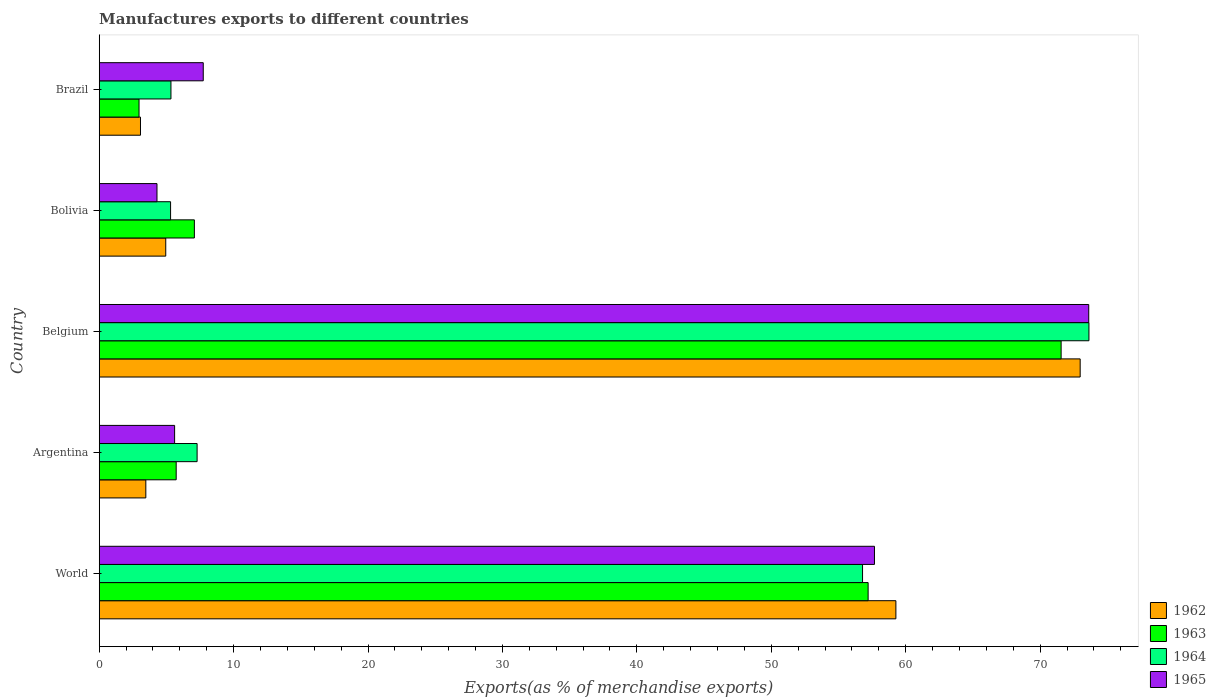How many different coloured bars are there?
Offer a terse response. 4. What is the label of the 4th group of bars from the top?
Offer a terse response. Argentina. In how many cases, is the number of bars for a given country not equal to the number of legend labels?
Provide a short and direct response. 0. What is the percentage of exports to different countries in 1964 in Argentina?
Offer a terse response. 7.28. Across all countries, what is the maximum percentage of exports to different countries in 1964?
Provide a succinct answer. 73.63. Across all countries, what is the minimum percentage of exports to different countries in 1965?
Your answer should be compact. 4.3. In which country was the percentage of exports to different countries in 1965 maximum?
Make the answer very short. Belgium. What is the total percentage of exports to different countries in 1962 in the graph?
Give a very brief answer. 143.74. What is the difference between the percentage of exports to different countries in 1963 in Argentina and that in World?
Offer a very short reply. -51.48. What is the difference between the percentage of exports to different countries in 1963 in Bolivia and the percentage of exports to different countries in 1965 in World?
Offer a very short reply. -50.6. What is the average percentage of exports to different countries in 1962 per country?
Offer a terse response. 28.75. What is the difference between the percentage of exports to different countries in 1963 and percentage of exports to different countries in 1962 in Bolivia?
Your response must be concise. 2.13. In how many countries, is the percentage of exports to different countries in 1963 greater than 44 %?
Offer a terse response. 2. What is the ratio of the percentage of exports to different countries in 1962 in Argentina to that in Belgium?
Offer a terse response. 0.05. Is the difference between the percentage of exports to different countries in 1963 in Argentina and Bolivia greater than the difference between the percentage of exports to different countries in 1962 in Argentina and Bolivia?
Give a very brief answer. Yes. What is the difference between the highest and the second highest percentage of exports to different countries in 1962?
Keep it short and to the point. 13.71. What is the difference between the highest and the lowest percentage of exports to different countries in 1962?
Offer a terse response. 69.91. In how many countries, is the percentage of exports to different countries in 1963 greater than the average percentage of exports to different countries in 1963 taken over all countries?
Keep it short and to the point. 2. What does the 3rd bar from the top in Belgium represents?
Provide a succinct answer. 1963. What does the 2nd bar from the bottom in World represents?
Keep it short and to the point. 1963. Is it the case that in every country, the sum of the percentage of exports to different countries in 1963 and percentage of exports to different countries in 1965 is greater than the percentage of exports to different countries in 1962?
Provide a succinct answer. Yes. Are all the bars in the graph horizontal?
Keep it short and to the point. Yes. Are the values on the major ticks of X-axis written in scientific E-notation?
Offer a terse response. No. Does the graph contain any zero values?
Offer a very short reply. No. Does the graph contain grids?
Your answer should be compact. No. How many legend labels are there?
Keep it short and to the point. 4. What is the title of the graph?
Make the answer very short. Manufactures exports to different countries. What is the label or title of the X-axis?
Give a very brief answer. Exports(as % of merchandise exports). What is the Exports(as % of merchandise exports) of 1962 in World?
Provide a succinct answer. 59.27. What is the Exports(as % of merchandise exports) of 1963 in World?
Provide a succinct answer. 57.2. What is the Exports(as % of merchandise exports) in 1964 in World?
Provide a succinct answer. 56.79. What is the Exports(as % of merchandise exports) in 1965 in World?
Your answer should be very brief. 57.68. What is the Exports(as % of merchandise exports) of 1962 in Argentina?
Keep it short and to the point. 3.47. What is the Exports(as % of merchandise exports) in 1963 in Argentina?
Ensure brevity in your answer.  5.73. What is the Exports(as % of merchandise exports) of 1964 in Argentina?
Make the answer very short. 7.28. What is the Exports(as % of merchandise exports) of 1965 in Argentina?
Keep it short and to the point. 5.61. What is the Exports(as % of merchandise exports) of 1962 in Belgium?
Your answer should be very brief. 72.98. What is the Exports(as % of merchandise exports) of 1963 in Belgium?
Provide a succinct answer. 71.56. What is the Exports(as % of merchandise exports) in 1964 in Belgium?
Your answer should be very brief. 73.63. What is the Exports(as % of merchandise exports) in 1965 in Belgium?
Provide a short and direct response. 73.62. What is the Exports(as % of merchandise exports) of 1962 in Bolivia?
Your answer should be very brief. 4.95. What is the Exports(as % of merchandise exports) in 1963 in Bolivia?
Give a very brief answer. 7.08. What is the Exports(as % of merchandise exports) of 1964 in Bolivia?
Your answer should be compact. 5.31. What is the Exports(as % of merchandise exports) in 1965 in Bolivia?
Offer a terse response. 4.3. What is the Exports(as % of merchandise exports) of 1962 in Brazil?
Offer a very short reply. 3.07. What is the Exports(as % of merchandise exports) in 1963 in Brazil?
Ensure brevity in your answer.  2.96. What is the Exports(as % of merchandise exports) of 1964 in Brazil?
Give a very brief answer. 5.34. What is the Exports(as % of merchandise exports) of 1965 in Brazil?
Your answer should be compact. 7.74. Across all countries, what is the maximum Exports(as % of merchandise exports) in 1962?
Keep it short and to the point. 72.98. Across all countries, what is the maximum Exports(as % of merchandise exports) of 1963?
Keep it short and to the point. 71.56. Across all countries, what is the maximum Exports(as % of merchandise exports) in 1964?
Provide a short and direct response. 73.63. Across all countries, what is the maximum Exports(as % of merchandise exports) in 1965?
Offer a very short reply. 73.62. Across all countries, what is the minimum Exports(as % of merchandise exports) of 1962?
Provide a succinct answer. 3.07. Across all countries, what is the minimum Exports(as % of merchandise exports) in 1963?
Ensure brevity in your answer.  2.96. Across all countries, what is the minimum Exports(as % of merchandise exports) of 1964?
Ensure brevity in your answer.  5.31. Across all countries, what is the minimum Exports(as % of merchandise exports) of 1965?
Your answer should be very brief. 4.3. What is the total Exports(as % of merchandise exports) of 1962 in the graph?
Your response must be concise. 143.74. What is the total Exports(as % of merchandise exports) of 1963 in the graph?
Provide a short and direct response. 144.54. What is the total Exports(as % of merchandise exports) in 1964 in the graph?
Your response must be concise. 148.35. What is the total Exports(as % of merchandise exports) in 1965 in the graph?
Your answer should be compact. 148.94. What is the difference between the Exports(as % of merchandise exports) in 1962 in World and that in Argentina?
Keep it short and to the point. 55.8. What is the difference between the Exports(as % of merchandise exports) of 1963 in World and that in Argentina?
Your answer should be very brief. 51.48. What is the difference between the Exports(as % of merchandise exports) of 1964 in World and that in Argentina?
Offer a terse response. 49.51. What is the difference between the Exports(as % of merchandise exports) of 1965 in World and that in Argentina?
Keep it short and to the point. 52.07. What is the difference between the Exports(as % of merchandise exports) in 1962 in World and that in Belgium?
Keep it short and to the point. -13.71. What is the difference between the Exports(as % of merchandise exports) in 1963 in World and that in Belgium?
Ensure brevity in your answer.  -14.36. What is the difference between the Exports(as % of merchandise exports) in 1964 in World and that in Belgium?
Make the answer very short. -16.84. What is the difference between the Exports(as % of merchandise exports) of 1965 in World and that in Belgium?
Give a very brief answer. -15.94. What is the difference between the Exports(as % of merchandise exports) in 1962 in World and that in Bolivia?
Provide a succinct answer. 54.32. What is the difference between the Exports(as % of merchandise exports) of 1963 in World and that in Bolivia?
Your answer should be very brief. 50.12. What is the difference between the Exports(as % of merchandise exports) in 1964 in World and that in Bolivia?
Offer a very short reply. 51.48. What is the difference between the Exports(as % of merchandise exports) of 1965 in World and that in Bolivia?
Offer a very short reply. 53.38. What is the difference between the Exports(as % of merchandise exports) of 1962 in World and that in Brazil?
Your answer should be compact. 56.2. What is the difference between the Exports(as % of merchandise exports) of 1963 in World and that in Brazil?
Your response must be concise. 54.24. What is the difference between the Exports(as % of merchandise exports) of 1964 in World and that in Brazil?
Your response must be concise. 51.45. What is the difference between the Exports(as % of merchandise exports) of 1965 in World and that in Brazil?
Keep it short and to the point. 49.94. What is the difference between the Exports(as % of merchandise exports) in 1962 in Argentina and that in Belgium?
Offer a terse response. -69.51. What is the difference between the Exports(as % of merchandise exports) in 1963 in Argentina and that in Belgium?
Provide a succinct answer. -65.84. What is the difference between the Exports(as % of merchandise exports) in 1964 in Argentina and that in Belgium?
Your answer should be very brief. -66.35. What is the difference between the Exports(as % of merchandise exports) in 1965 in Argentina and that in Belgium?
Keep it short and to the point. -68.01. What is the difference between the Exports(as % of merchandise exports) of 1962 in Argentina and that in Bolivia?
Offer a very short reply. -1.48. What is the difference between the Exports(as % of merchandise exports) in 1963 in Argentina and that in Bolivia?
Offer a terse response. -1.35. What is the difference between the Exports(as % of merchandise exports) of 1964 in Argentina and that in Bolivia?
Your answer should be compact. 1.97. What is the difference between the Exports(as % of merchandise exports) of 1965 in Argentina and that in Bolivia?
Offer a terse response. 1.31. What is the difference between the Exports(as % of merchandise exports) in 1962 in Argentina and that in Brazil?
Your response must be concise. 0.4. What is the difference between the Exports(as % of merchandise exports) in 1963 in Argentina and that in Brazil?
Provide a succinct answer. 2.76. What is the difference between the Exports(as % of merchandise exports) in 1964 in Argentina and that in Brazil?
Provide a short and direct response. 1.95. What is the difference between the Exports(as % of merchandise exports) of 1965 in Argentina and that in Brazil?
Your answer should be very brief. -2.13. What is the difference between the Exports(as % of merchandise exports) in 1962 in Belgium and that in Bolivia?
Your answer should be very brief. 68.03. What is the difference between the Exports(as % of merchandise exports) in 1963 in Belgium and that in Bolivia?
Make the answer very short. 64.48. What is the difference between the Exports(as % of merchandise exports) of 1964 in Belgium and that in Bolivia?
Keep it short and to the point. 68.32. What is the difference between the Exports(as % of merchandise exports) in 1965 in Belgium and that in Bolivia?
Keep it short and to the point. 69.32. What is the difference between the Exports(as % of merchandise exports) of 1962 in Belgium and that in Brazil?
Provide a short and direct response. 69.91. What is the difference between the Exports(as % of merchandise exports) in 1963 in Belgium and that in Brazil?
Keep it short and to the point. 68.6. What is the difference between the Exports(as % of merchandise exports) in 1964 in Belgium and that in Brazil?
Make the answer very short. 68.3. What is the difference between the Exports(as % of merchandise exports) of 1965 in Belgium and that in Brazil?
Make the answer very short. 65.88. What is the difference between the Exports(as % of merchandise exports) of 1962 in Bolivia and that in Brazil?
Give a very brief answer. 1.88. What is the difference between the Exports(as % of merchandise exports) of 1963 in Bolivia and that in Brazil?
Offer a terse response. 4.12. What is the difference between the Exports(as % of merchandise exports) in 1964 in Bolivia and that in Brazil?
Your answer should be very brief. -0.03. What is the difference between the Exports(as % of merchandise exports) in 1965 in Bolivia and that in Brazil?
Give a very brief answer. -3.44. What is the difference between the Exports(as % of merchandise exports) of 1962 in World and the Exports(as % of merchandise exports) of 1963 in Argentina?
Ensure brevity in your answer.  53.55. What is the difference between the Exports(as % of merchandise exports) in 1962 in World and the Exports(as % of merchandise exports) in 1964 in Argentina?
Your answer should be very brief. 51.99. What is the difference between the Exports(as % of merchandise exports) of 1962 in World and the Exports(as % of merchandise exports) of 1965 in Argentina?
Provide a short and direct response. 53.66. What is the difference between the Exports(as % of merchandise exports) in 1963 in World and the Exports(as % of merchandise exports) in 1964 in Argentina?
Make the answer very short. 49.92. What is the difference between the Exports(as % of merchandise exports) in 1963 in World and the Exports(as % of merchandise exports) in 1965 in Argentina?
Provide a short and direct response. 51.59. What is the difference between the Exports(as % of merchandise exports) of 1964 in World and the Exports(as % of merchandise exports) of 1965 in Argentina?
Make the answer very short. 51.18. What is the difference between the Exports(as % of merchandise exports) of 1962 in World and the Exports(as % of merchandise exports) of 1963 in Belgium?
Give a very brief answer. -12.29. What is the difference between the Exports(as % of merchandise exports) of 1962 in World and the Exports(as % of merchandise exports) of 1964 in Belgium?
Make the answer very short. -14.36. What is the difference between the Exports(as % of merchandise exports) of 1962 in World and the Exports(as % of merchandise exports) of 1965 in Belgium?
Offer a terse response. -14.35. What is the difference between the Exports(as % of merchandise exports) of 1963 in World and the Exports(as % of merchandise exports) of 1964 in Belgium?
Make the answer very short. -16.43. What is the difference between the Exports(as % of merchandise exports) in 1963 in World and the Exports(as % of merchandise exports) in 1965 in Belgium?
Your answer should be compact. -16.41. What is the difference between the Exports(as % of merchandise exports) in 1964 in World and the Exports(as % of merchandise exports) in 1965 in Belgium?
Ensure brevity in your answer.  -16.83. What is the difference between the Exports(as % of merchandise exports) in 1962 in World and the Exports(as % of merchandise exports) in 1963 in Bolivia?
Ensure brevity in your answer.  52.19. What is the difference between the Exports(as % of merchandise exports) of 1962 in World and the Exports(as % of merchandise exports) of 1964 in Bolivia?
Provide a short and direct response. 53.96. What is the difference between the Exports(as % of merchandise exports) in 1962 in World and the Exports(as % of merchandise exports) in 1965 in Bolivia?
Provide a short and direct response. 54.97. What is the difference between the Exports(as % of merchandise exports) in 1963 in World and the Exports(as % of merchandise exports) in 1964 in Bolivia?
Offer a terse response. 51.89. What is the difference between the Exports(as % of merchandise exports) of 1963 in World and the Exports(as % of merchandise exports) of 1965 in Bolivia?
Offer a terse response. 52.91. What is the difference between the Exports(as % of merchandise exports) in 1964 in World and the Exports(as % of merchandise exports) in 1965 in Bolivia?
Provide a short and direct response. 52.49. What is the difference between the Exports(as % of merchandise exports) in 1962 in World and the Exports(as % of merchandise exports) in 1963 in Brazil?
Ensure brevity in your answer.  56.31. What is the difference between the Exports(as % of merchandise exports) of 1962 in World and the Exports(as % of merchandise exports) of 1964 in Brazil?
Your response must be concise. 53.93. What is the difference between the Exports(as % of merchandise exports) in 1962 in World and the Exports(as % of merchandise exports) in 1965 in Brazil?
Ensure brevity in your answer.  51.53. What is the difference between the Exports(as % of merchandise exports) of 1963 in World and the Exports(as % of merchandise exports) of 1964 in Brazil?
Your answer should be compact. 51.87. What is the difference between the Exports(as % of merchandise exports) in 1963 in World and the Exports(as % of merchandise exports) in 1965 in Brazil?
Your answer should be very brief. 49.46. What is the difference between the Exports(as % of merchandise exports) in 1964 in World and the Exports(as % of merchandise exports) in 1965 in Brazil?
Provide a short and direct response. 49.05. What is the difference between the Exports(as % of merchandise exports) in 1962 in Argentina and the Exports(as % of merchandise exports) in 1963 in Belgium?
Your answer should be compact. -68.1. What is the difference between the Exports(as % of merchandise exports) of 1962 in Argentina and the Exports(as % of merchandise exports) of 1964 in Belgium?
Keep it short and to the point. -70.16. What is the difference between the Exports(as % of merchandise exports) in 1962 in Argentina and the Exports(as % of merchandise exports) in 1965 in Belgium?
Ensure brevity in your answer.  -70.15. What is the difference between the Exports(as % of merchandise exports) of 1963 in Argentina and the Exports(as % of merchandise exports) of 1964 in Belgium?
Make the answer very short. -67.91. What is the difference between the Exports(as % of merchandise exports) in 1963 in Argentina and the Exports(as % of merchandise exports) in 1965 in Belgium?
Keep it short and to the point. -67.89. What is the difference between the Exports(as % of merchandise exports) of 1964 in Argentina and the Exports(as % of merchandise exports) of 1965 in Belgium?
Give a very brief answer. -66.33. What is the difference between the Exports(as % of merchandise exports) in 1962 in Argentina and the Exports(as % of merchandise exports) in 1963 in Bolivia?
Your answer should be very brief. -3.61. What is the difference between the Exports(as % of merchandise exports) of 1962 in Argentina and the Exports(as % of merchandise exports) of 1964 in Bolivia?
Provide a short and direct response. -1.84. What is the difference between the Exports(as % of merchandise exports) in 1962 in Argentina and the Exports(as % of merchandise exports) in 1965 in Bolivia?
Provide a succinct answer. -0.83. What is the difference between the Exports(as % of merchandise exports) of 1963 in Argentina and the Exports(as % of merchandise exports) of 1964 in Bolivia?
Your answer should be very brief. 0.42. What is the difference between the Exports(as % of merchandise exports) in 1963 in Argentina and the Exports(as % of merchandise exports) in 1965 in Bolivia?
Your answer should be very brief. 1.43. What is the difference between the Exports(as % of merchandise exports) in 1964 in Argentina and the Exports(as % of merchandise exports) in 1965 in Bolivia?
Offer a terse response. 2.98. What is the difference between the Exports(as % of merchandise exports) of 1962 in Argentina and the Exports(as % of merchandise exports) of 1963 in Brazil?
Give a very brief answer. 0.51. What is the difference between the Exports(as % of merchandise exports) of 1962 in Argentina and the Exports(as % of merchandise exports) of 1964 in Brazil?
Provide a succinct answer. -1.87. What is the difference between the Exports(as % of merchandise exports) in 1962 in Argentina and the Exports(as % of merchandise exports) in 1965 in Brazil?
Give a very brief answer. -4.27. What is the difference between the Exports(as % of merchandise exports) in 1963 in Argentina and the Exports(as % of merchandise exports) in 1964 in Brazil?
Your answer should be compact. 0.39. What is the difference between the Exports(as % of merchandise exports) of 1963 in Argentina and the Exports(as % of merchandise exports) of 1965 in Brazil?
Provide a succinct answer. -2.01. What is the difference between the Exports(as % of merchandise exports) of 1964 in Argentina and the Exports(as % of merchandise exports) of 1965 in Brazil?
Offer a terse response. -0.46. What is the difference between the Exports(as % of merchandise exports) in 1962 in Belgium and the Exports(as % of merchandise exports) in 1963 in Bolivia?
Provide a succinct answer. 65.9. What is the difference between the Exports(as % of merchandise exports) in 1962 in Belgium and the Exports(as % of merchandise exports) in 1964 in Bolivia?
Provide a succinct answer. 67.67. What is the difference between the Exports(as % of merchandise exports) of 1962 in Belgium and the Exports(as % of merchandise exports) of 1965 in Bolivia?
Your answer should be very brief. 68.68. What is the difference between the Exports(as % of merchandise exports) of 1963 in Belgium and the Exports(as % of merchandise exports) of 1964 in Bolivia?
Your answer should be very brief. 66.25. What is the difference between the Exports(as % of merchandise exports) in 1963 in Belgium and the Exports(as % of merchandise exports) in 1965 in Bolivia?
Provide a short and direct response. 67.27. What is the difference between the Exports(as % of merchandise exports) in 1964 in Belgium and the Exports(as % of merchandise exports) in 1965 in Bolivia?
Make the answer very short. 69.34. What is the difference between the Exports(as % of merchandise exports) in 1962 in Belgium and the Exports(as % of merchandise exports) in 1963 in Brazil?
Ensure brevity in your answer.  70.02. What is the difference between the Exports(as % of merchandise exports) in 1962 in Belgium and the Exports(as % of merchandise exports) in 1964 in Brazil?
Your answer should be compact. 67.64. What is the difference between the Exports(as % of merchandise exports) of 1962 in Belgium and the Exports(as % of merchandise exports) of 1965 in Brazil?
Offer a very short reply. 65.24. What is the difference between the Exports(as % of merchandise exports) in 1963 in Belgium and the Exports(as % of merchandise exports) in 1964 in Brazil?
Provide a succinct answer. 66.23. What is the difference between the Exports(as % of merchandise exports) in 1963 in Belgium and the Exports(as % of merchandise exports) in 1965 in Brazil?
Your answer should be compact. 63.82. What is the difference between the Exports(as % of merchandise exports) of 1964 in Belgium and the Exports(as % of merchandise exports) of 1965 in Brazil?
Provide a succinct answer. 65.89. What is the difference between the Exports(as % of merchandise exports) in 1962 in Bolivia and the Exports(as % of merchandise exports) in 1963 in Brazil?
Your answer should be very brief. 1.99. What is the difference between the Exports(as % of merchandise exports) of 1962 in Bolivia and the Exports(as % of merchandise exports) of 1964 in Brazil?
Ensure brevity in your answer.  -0.39. What is the difference between the Exports(as % of merchandise exports) in 1962 in Bolivia and the Exports(as % of merchandise exports) in 1965 in Brazil?
Provide a short and direct response. -2.79. What is the difference between the Exports(as % of merchandise exports) of 1963 in Bolivia and the Exports(as % of merchandise exports) of 1964 in Brazil?
Your answer should be compact. 1.74. What is the difference between the Exports(as % of merchandise exports) in 1963 in Bolivia and the Exports(as % of merchandise exports) in 1965 in Brazil?
Provide a succinct answer. -0.66. What is the difference between the Exports(as % of merchandise exports) in 1964 in Bolivia and the Exports(as % of merchandise exports) in 1965 in Brazil?
Your response must be concise. -2.43. What is the average Exports(as % of merchandise exports) of 1962 per country?
Your response must be concise. 28.75. What is the average Exports(as % of merchandise exports) in 1963 per country?
Your answer should be very brief. 28.91. What is the average Exports(as % of merchandise exports) in 1964 per country?
Ensure brevity in your answer.  29.67. What is the average Exports(as % of merchandise exports) of 1965 per country?
Make the answer very short. 29.79. What is the difference between the Exports(as % of merchandise exports) in 1962 and Exports(as % of merchandise exports) in 1963 in World?
Provide a succinct answer. 2.07. What is the difference between the Exports(as % of merchandise exports) of 1962 and Exports(as % of merchandise exports) of 1964 in World?
Your response must be concise. 2.48. What is the difference between the Exports(as % of merchandise exports) in 1962 and Exports(as % of merchandise exports) in 1965 in World?
Keep it short and to the point. 1.59. What is the difference between the Exports(as % of merchandise exports) in 1963 and Exports(as % of merchandise exports) in 1964 in World?
Offer a terse response. 0.41. What is the difference between the Exports(as % of merchandise exports) of 1963 and Exports(as % of merchandise exports) of 1965 in World?
Provide a short and direct response. -0.47. What is the difference between the Exports(as % of merchandise exports) of 1964 and Exports(as % of merchandise exports) of 1965 in World?
Your answer should be compact. -0.89. What is the difference between the Exports(as % of merchandise exports) of 1962 and Exports(as % of merchandise exports) of 1963 in Argentina?
Your answer should be very brief. -2.26. What is the difference between the Exports(as % of merchandise exports) of 1962 and Exports(as % of merchandise exports) of 1964 in Argentina?
Make the answer very short. -3.81. What is the difference between the Exports(as % of merchandise exports) in 1962 and Exports(as % of merchandise exports) in 1965 in Argentina?
Your answer should be compact. -2.14. What is the difference between the Exports(as % of merchandise exports) of 1963 and Exports(as % of merchandise exports) of 1964 in Argentina?
Make the answer very short. -1.56. What is the difference between the Exports(as % of merchandise exports) of 1963 and Exports(as % of merchandise exports) of 1965 in Argentina?
Make the answer very short. 0.12. What is the difference between the Exports(as % of merchandise exports) in 1964 and Exports(as % of merchandise exports) in 1965 in Argentina?
Provide a succinct answer. 1.67. What is the difference between the Exports(as % of merchandise exports) of 1962 and Exports(as % of merchandise exports) of 1963 in Belgium?
Offer a terse response. 1.42. What is the difference between the Exports(as % of merchandise exports) in 1962 and Exports(as % of merchandise exports) in 1964 in Belgium?
Provide a succinct answer. -0.65. What is the difference between the Exports(as % of merchandise exports) in 1962 and Exports(as % of merchandise exports) in 1965 in Belgium?
Give a very brief answer. -0.64. What is the difference between the Exports(as % of merchandise exports) of 1963 and Exports(as % of merchandise exports) of 1964 in Belgium?
Provide a short and direct response. -2.07. What is the difference between the Exports(as % of merchandise exports) in 1963 and Exports(as % of merchandise exports) in 1965 in Belgium?
Offer a very short reply. -2.05. What is the difference between the Exports(as % of merchandise exports) in 1964 and Exports(as % of merchandise exports) in 1965 in Belgium?
Your answer should be very brief. 0.02. What is the difference between the Exports(as % of merchandise exports) of 1962 and Exports(as % of merchandise exports) of 1963 in Bolivia?
Your response must be concise. -2.13. What is the difference between the Exports(as % of merchandise exports) in 1962 and Exports(as % of merchandise exports) in 1964 in Bolivia?
Provide a short and direct response. -0.36. What is the difference between the Exports(as % of merchandise exports) in 1962 and Exports(as % of merchandise exports) in 1965 in Bolivia?
Offer a terse response. 0.65. What is the difference between the Exports(as % of merchandise exports) of 1963 and Exports(as % of merchandise exports) of 1964 in Bolivia?
Make the answer very short. 1.77. What is the difference between the Exports(as % of merchandise exports) of 1963 and Exports(as % of merchandise exports) of 1965 in Bolivia?
Offer a very short reply. 2.78. What is the difference between the Exports(as % of merchandise exports) of 1964 and Exports(as % of merchandise exports) of 1965 in Bolivia?
Your answer should be very brief. 1.01. What is the difference between the Exports(as % of merchandise exports) in 1962 and Exports(as % of merchandise exports) in 1963 in Brazil?
Keep it short and to the point. 0.11. What is the difference between the Exports(as % of merchandise exports) in 1962 and Exports(as % of merchandise exports) in 1964 in Brazil?
Your answer should be compact. -2.27. What is the difference between the Exports(as % of merchandise exports) in 1962 and Exports(as % of merchandise exports) in 1965 in Brazil?
Offer a terse response. -4.67. What is the difference between the Exports(as % of merchandise exports) in 1963 and Exports(as % of merchandise exports) in 1964 in Brazil?
Give a very brief answer. -2.37. What is the difference between the Exports(as % of merchandise exports) of 1963 and Exports(as % of merchandise exports) of 1965 in Brazil?
Your answer should be compact. -4.78. What is the difference between the Exports(as % of merchandise exports) of 1964 and Exports(as % of merchandise exports) of 1965 in Brazil?
Offer a terse response. -2.4. What is the ratio of the Exports(as % of merchandise exports) in 1962 in World to that in Argentina?
Make the answer very short. 17.09. What is the ratio of the Exports(as % of merchandise exports) in 1963 in World to that in Argentina?
Your answer should be very brief. 9.99. What is the ratio of the Exports(as % of merchandise exports) in 1964 in World to that in Argentina?
Offer a very short reply. 7.8. What is the ratio of the Exports(as % of merchandise exports) in 1965 in World to that in Argentina?
Keep it short and to the point. 10.28. What is the ratio of the Exports(as % of merchandise exports) in 1962 in World to that in Belgium?
Your response must be concise. 0.81. What is the ratio of the Exports(as % of merchandise exports) in 1963 in World to that in Belgium?
Provide a short and direct response. 0.8. What is the ratio of the Exports(as % of merchandise exports) in 1964 in World to that in Belgium?
Provide a short and direct response. 0.77. What is the ratio of the Exports(as % of merchandise exports) of 1965 in World to that in Belgium?
Ensure brevity in your answer.  0.78. What is the ratio of the Exports(as % of merchandise exports) in 1962 in World to that in Bolivia?
Your answer should be very brief. 11.97. What is the ratio of the Exports(as % of merchandise exports) of 1963 in World to that in Bolivia?
Offer a terse response. 8.08. What is the ratio of the Exports(as % of merchandise exports) of 1964 in World to that in Bolivia?
Your response must be concise. 10.7. What is the ratio of the Exports(as % of merchandise exports) in 1965 in World to that in Bolivia?
Ensure brevity in your answer.  13.42. What is the ratio of the Exports(as % of merchandise exports) in 1962 in World to that in Brazil?
Your response must be concise. 19.3. What is the ratio of the Exports(as % of merchandise exports) in 1963 in World to that in Brazil?
Ensure brevity in your answer.  19.31. What is the ratio of the Exports(as % of merchandise exports) in 1964 in World to that in Brazil?
Your response must be concise. 10.64. What is the ratio of the Exports(as % of merchandise exports) of 1965 in World to that in Brazil?
Give a very brief answer. 7.45. What is the ratio of the Exports(as % of merchandise exports) of 1962 in Argentina to that in Belgium?
Provide a succinct answer. 0.05. What is the ratio of the Exports(as % of merchandise exports) in 1963 in Argentina to that in Belgium?
Your answer should be very brief. 0.08. What is the ratio of the Exports(as % of merchandise exports) in 1964 in Argentina to that in Belgium?
Provide a short and direct response. 0.1. What is the ratio of the Exports(as % of merchandise exports) in 1965 in Argentina to that in Belgium?
Provide a short and direct response. 0.08. What is the ratio of the Exports(as % of merchandise exports) in 1962 in Argentina to that in Bolivia?
Make the answer very short. 0.7. What is the ratio of the Exports(as % of merchandise exports) in 1963 in Argentina to that in Bolivia?
Provide a succinct answer. 0.81. What is the ratio of the Exports(as % of merchandise exports) of 1964 in Argentina to that in Bolivia?
Ensure brevity in your answer.  1.37. What is the ratio of the Exports(as % of merchandise exports) of 1965 in Argentina to that in Bolivia?
Keep it short and to the point. 1.31. What is the ratio of the Exports(as % of merchandise exports) of 1962 in Argentina to that in Brazil?
Offer a very short reply. 1.13. What is the ratio of the Exports(as % of merchandise exports) of 1963 in Argentina to that in Brazil?
Make the answer very short. 1.93. What is the ratio of the Exports(as % of merchandise exports) in 1964 in Argentina to that in Brazil?
Your response must be concise. 1.36. What is the ratio of the Exports(as % of merchandise exports) of 1965 in Argentina to that in Brazil?
Ensure brevity in your answer.  0.72. What is the ratio of the Exports(as % of merchandise exports) of 1962 in Belgium to that in Bolivia?
Ensure brevity in your answer.  14.74. What is the ratio of the Exports(as % of merchandise exports) in 1963 in Belgium to that in Bolivia?
Ensure brevity in your answer.  10.11. What is the ratio of the Exports(as % of merchandise exports) in 1964 in Belgium to that in Bolivia?
Ensure brevity in your answer.  13.87. What is the ratio of the Exports(as % of merchandise exports) of 1965 in Belgium to that in Bolivia?
Your answer should be compact. 17.13. What is the ratio of the Exports(as % of merchandise exports) of 1962 in Belgium to that in Brazil?
Provide a short and direct response. 23.77. What is the ratio of the Exports(as % of merchandise exports) in 1963 in Belgium to that in Brazil?
Make the answer very short. 24.16. What is the ratio of the Exports(as % of merchandise exports) in 1964 in Belgium to that in Brazil?
Offer a terse response. 13.8. What is the ratio of the Exports(as % of merchandise exports) in 1965 in Belgium to that in Brazil?
Make the answer very short. 9.51. What is the ratio of the Exports(as % of merchandise exports) of 1962 in Bolivia to that in Brazil?
Keep it short and to the point. 1.61. What is the ratio of the Exports(as % of merchandise exports) in 1963 in Bolivia to that in Brazil?
Your response must be concise. 2.39. What is the ratio of the Exports(as % of merchandise exports) of 1964 in Bolivia to that in Brazil?
Ensure brevity in your answer.  0.99. What is the ratio of the Exports(as % of merchandise exports) in 1965 in Bolivia to that in Brazil?
Provide a short and direct response. 0.56. What is the difference between the highest and the second highest Exports(as % of merchandise exports) of 1962?
Provide a short and direct response. 13.71. What is the difference between the highest and the second highest Exports(as % of merchandise exports) in 1963?
Your answer should be very brief. 14.36. What is the difference between the highest and the second highest Exports(as % of merchandise exports) of 1964?
Provide a succinct answer. 16.84. What is the difference between the highest and the second highest Exports(as % of merchandise exports) in 1965?
Keep it short and to the point. 15.94. What is the difference between the highest and the lowest Exports(as % of merchandise exports) of 1962?
Provide a short and direct response. 69.91. What is the difference between the highest and the lowest Exports(as % of merchandise exports) in 1963?
Your answer should be compact. 68.6. What is the difference between the highest and the lowest Exports(as % of merchandise exports) in 1964?
Your answer should be compact. 68.32. What is the difference between the highest and the lowest Exports(as % of merchandise exports) of 1965?
Provide a short and direct response. 69.32. 